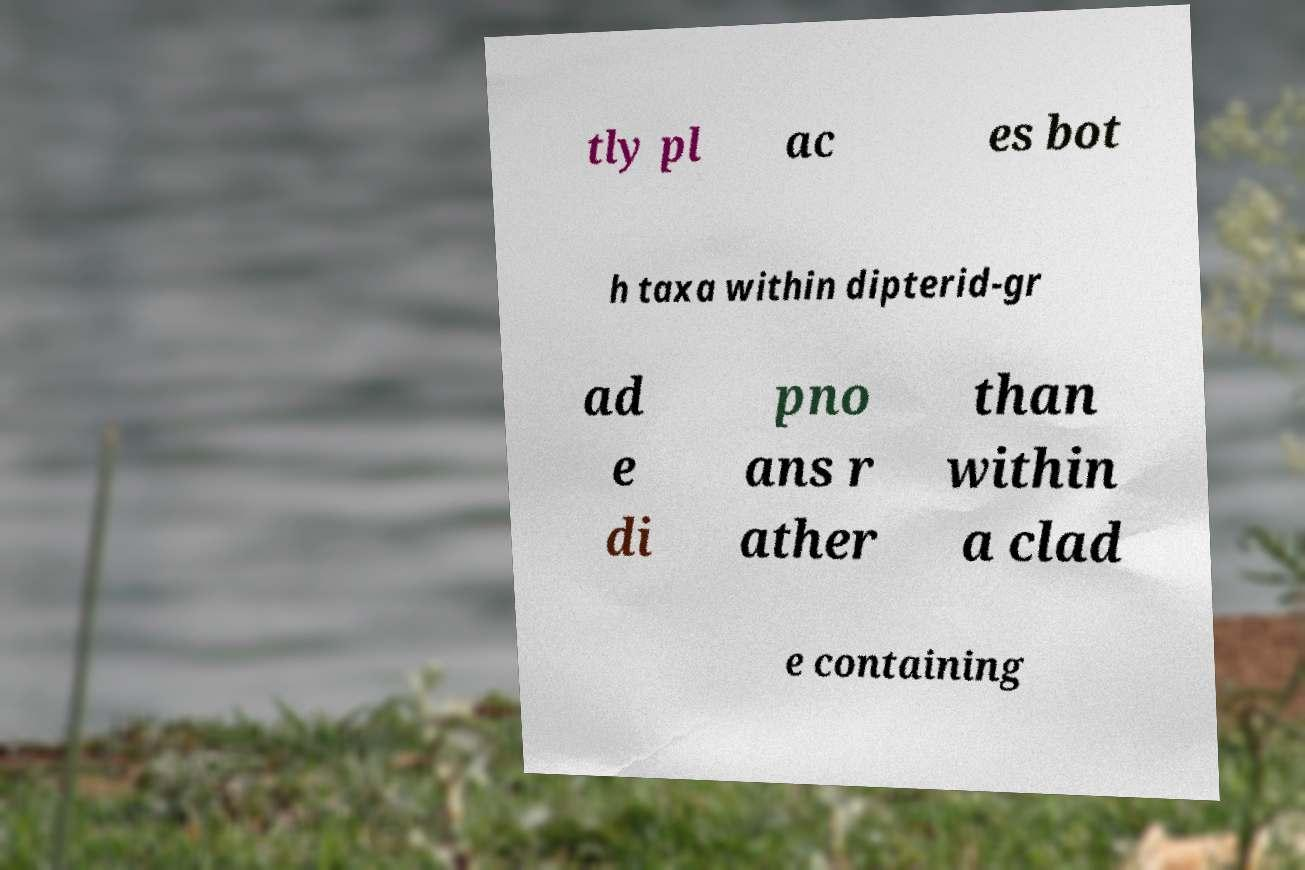I need the written content from this picture converted into text. Can you do that? tly pl ac es bot h taxa within dipterid-gr ad e di pno ans r ather than within a clad e containing 